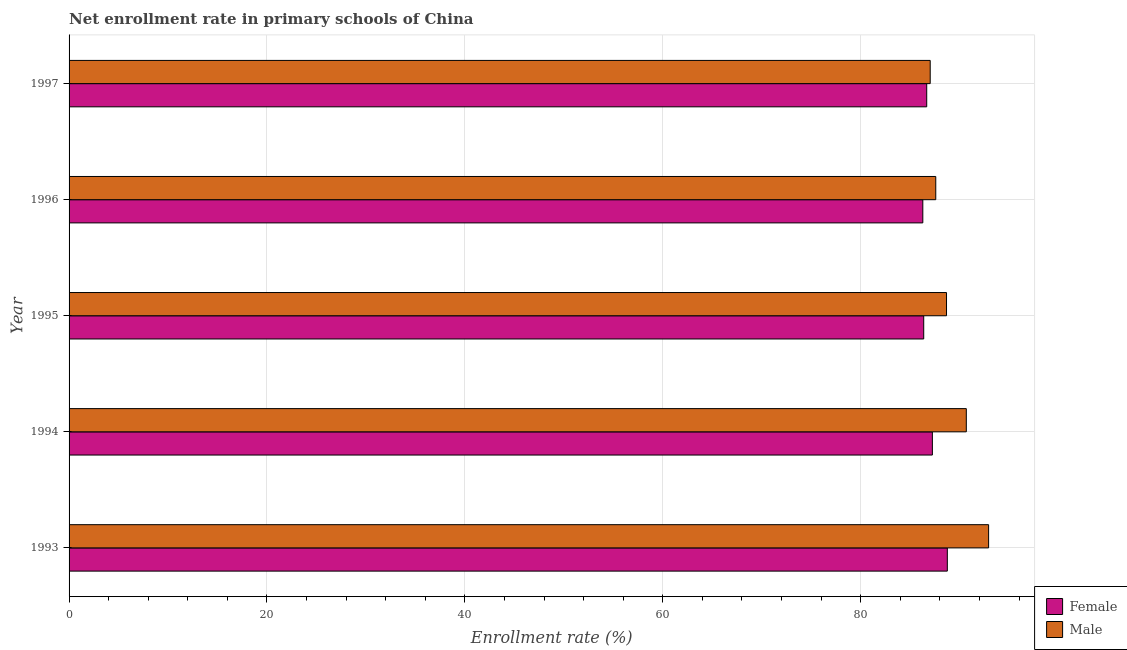How many groups of bars are there?
Give a very brief answer. 5. Are the number of bars per tick equal to the number of legend labels?
Provide a succinct answer. Yes. How many bars are there on the 5th tick from the top?
Offer a very short reply. 2. How many bars are there on the 1st tick from the bottom?
Provide a short and direct response. 2. What is the enrollment rate of male students in 1996?
Offer a terse response. 87.58. Across all years, what is the maximum enrollment rate of male students?
Provide a succinct answer. 92.93. Across all years, what is the minimum enrollment rate of male students?
Provide a succinct answer. 87.02. In which year was the enrollment rate of female students maximum?
Offer a very short reply. 1993. In which year was the enrollment rate of male students minimum?
Provide a short and direct response. 1997. What is the total enrollment rate of male students in the graph?
Keep it short and to the point. 446.88. What is the difference between the enrollment rate of female students in 1993 and that in 1994?
Give a very brief answer. 1.51. What is the difference between the enrollment rate of female students in 1996 and the enrollment rate of male students in 1993?
Your answer should be very brief. -6.65. What is the average enrollment rate of female students per year?
Provide a succinct answer. 87.06. In the year 1993, what is the difference between the enrollment rate of male students and enrollment rate of female students?
Your answer should be compact. 4.17. What is the ratio of the enrollment rate of male students in 1993 to that in 1997?
Make the answer very short. 1.07. Is the difference between the enrollment rate of male students in 1994 and 1996 greater than the difference between the enrollment rate of female students in 1994 and 1996?
Your response must be concise. Yes. What is the difference between the highest and the second highest enrollment rate of female students?
Ensure brevity in your answer.  1.51. What is the difference between the highest and the lowest enrollment rate of female students?
Keep it short and to the point. 2.48. Is the sum of the enrollment rate of male students in 1993 and 1997 greater than the maximum enrollment rate of female students across all years?
Your response must be concise. Yes. What does the 2nd bar from the top in 1997 represents?
Your answer should be compact. Female. Are all the bars in the graph horizontal?
Your response must be concise. Yes. How many years are there in the graph?
Keep it short and to the point. 5. Does the graph contain any zero values?
Give a very brief answer. No. Where does the legend appear in the graph?
Offer a terse response. Bottom right. How many legend labels are there?
Your answer should be compact. 2. What is the title of the graph?
Keep it short and to the point. Net enrollment rate in primary schools of China. Does "Highest 20% of population" appear as one of the legend labels in the graph?
Your answer should be very brief. No. What is the label or title of the X-axis?
Your response must be concise. Enrollment rate (%). What is the label or title of the Y-axis?
Make the answer very short. Year. What is the Enrollment rate (%) of Female in 1993?
Offer a terse response. 88.75. What is the Enrollment rate (%) in Male in 1993?
Offer a terse response. 92.93. What is the Enrollment rate (%) of Female in 1994?
Your answer should be very brief. 87.24. What is the Enrollment rate (%) of Male in 1994?
Provide a short and direct response. 90.67. What is the Enrollment rate (%) of Female in 1995?
Your answer should be compact. 86.37. What is the Enrollment rate (%) of Male in 1995?
Your answer should be very brief. 88.67. What is the Enrollment rate (%) of Female in 1996?
Provide a succinct answer. 86.28. What is the Enrollment rate (%) in Male in 1996?
Offer a very short reply. 87.58. What is the Enrollment rate (%) of Female in 1997?
Your answer should be compact. 86.67. What is the Enrollment rate (%) of Male in 1997?
Give a very brief answer. 87.02. Across all years, what is the maximum Enrollment rate (%) of Female?
Keep it short and to the point. 88.75. Across all years, what is the maximum Enrollment rate (%) in Male?
Offer a very short reply. 92.93. Across all years, what is the minimum Enrollment rate (%) of Female?
Offer a terse response. 86.28. Across all years, what is the minimum Enrollment rate (%) of Male?
Provide a short and direct response. 87.02. What is the total Enrollment rate (%) of Female in the graph?
Offer a terse response. 435.31. What is the total Enrollment rate (%) of Male in the graph?
Keep it short and to the point. 446.88. What is the difference between the Enrollment rate (%) in Female in 1993 and that in 1994?
Offer a very short reply. 1.51. What is the difference between the Enrollment rate (%) of Male in 1993 and that in 1994?
Offer a terse response. 2.25. What is the difference between the Enrollment rate (%) in Female in 1993 and that in 1995?
Offer a very short reply. 2.39. What is the difference between the Enrollment rate (%) of Male in 1993 and that in 1995?
Make the answer very short. 4.25. What is the difference between the Enrollment rate (%) of Female in 1993 and that in 1996?
Your answer should be very brief. 2.48. What is the difference between the Enrollment rate (%) of Male in 1993 and that in 1996?
Offer a very short reply. 5.34. What is the difference between the Enrollment rate (%) of Female in 1993 and that in 1997?
Provide a short and direct response. 2.08. What is the difference between the Enrollment rate (%) in Male in 1993 and that in 1997?
Your answer should be very brief. 5.9. What is the difference between the Enrollment rate (%) in Female in 1994 and that in 1995?
Offer a very short reply. 0.88. What is the difference between the Enrollment rate (%) in Male in 1994 and that in 1995?
Offer a very short reply. 2. What is the difference between the Enrollment rate (%) in Female in 1994 and that in 1996?
Your response must be concise. 0.97. What is the difference between the Enrollment rate (%) in Male in 1994 and that in 1996?
Provide a succinct answer. 3.09. What is the difference between the Enrollment rate (%) of Female in 1994 and that in 1997?
Offer a terse response. 0.57. What is the difference between the Enrollment rate (%) of Male in 1994 and that in 1997?
Ensure brevity in your answer.  3.65. What is the difference between the Enrollment rate (%) of Female in 1995 and that in 1996?
Your answer should be very brief. 0.09. What is the difference between the Enrollment rate (%) in Male in 1995 and that in 1996?
Your response must be concise. 1.09. What is the difference between the Enrollment rate (%) of Female in 1995 and that in 1997?
Offer a very short reply. -0.3. What is the difference between the Enrollment rate (%) in Male in 1995 and that in 1997?
Your answer should be very brief. 1.65. What is the difference between the Enrollment rate (%) of Female in 1996 and that in 1997?
Offer a very short reply. -0.39. What is the difference between the Enrollment rate (%) of Male in 1996 and that in 1997?
Keep it short and to the point. 0.56. What is the difference between the Enrollment rate (%) of Female in 1993 and the Enrollment rate (%) of Male in 1994?
Give a very brief answer. -1.92. What is the difference between the Enrollment rate (%) of Female in 1993 and the Enrollment rate (%) of Male in 1995?
Your answer should be very brief. 0.08. What is the difference between the Enrollment rate (%) of Female in 1993 and the Enrollment rate (%) of Male in 1996?
Your answer should be compact. 1.17. What is the difference between the Enrollment rate (%) of Female in 1993 and the Enrollment rate (%) of Male in 1997?
Give a very brief answer. 1.73. What is the difference between the Enrollment rate (%) in Female in 1994 and the Enrollment rate (%) in Male in 1995?
Provide a succinct answer. -1.43. What is the difference between the Enrollment rate (%) in Female in 1994 and the Enrollment rate (%) in Male in 1996?
Provide a succinct answer. -0.34. What is the difference between the Enrollment rate (%) in Female in 1994 and the Enrollment rate (%) in Male in 1997?
Keep it short and to the point. 0.22. What is the difference between the Enrollment rate (%) of Female in 1995 and the Enrollment rate (%) of Male in 1996?
Offer a very short reply. -1.22. What is the difference between the Enrollment rate (%) of Female in 1995 and the Enrollment rate (%) of Male in 1997?
Your answer should be compact. -0.66. What is the difference between the Enrollment rate (%) of Female in 1996 and the Enrollment rate (%) of Male in 1997?
Offer a very short reply. -0.75. What is the average Enrollment rate (%) in Female per year?
Give a very brief answer. 87.06. What is the average Enrollment rate (%) in Male per year?
Offer a terse response. 89.38. In the year 1993, what is the difference between the Enrollment rate (%) of Female and Enrollment rate (%) of Male?
Make the answer very short. -4.17. In the year 1994, what is the difference between the Enrollment rate (%) in Female and Enrollment rate (%) in Male?
Make the answer very short. -3.43. In the year 1995, what is the difference between the Enrollment rate (%) of Female and Enrollment rate (%) of Male?
Provide a short and direct response. -2.3. In the year 1996, what is the difference between the Enrollment rate (%) in Female and Enrollment rate (%) in Male?
Offer a very short reply. -1.31. In the year 1997, what is the difference between the Enrollment rate (%) in Female and Enrollment rate (%) in Male?
Give a very brief answer. -0.35. What is the ratio of the Enrollment rate (%) in Female in 1993 to that in 1994?
Your response must be concise. 1.02. What is the ratio of the Enrollment rate (%) in Male in 1993 to that in 1994?
Your response must be concise. 1.02. What is the ratio of the Enrollment rate (%) in Female in 1993 to that in 1995?
Ensure brevity in your answer.  1.03. What is the ratio of the Enrollment rate (%) in Male in 1993 to that in 1995?
Your answer should be very brief. 1.05. What is the ratio of the Enrollment rate (%) of Female in 1993 to that in 1996?
Offer a very short reply. 1.03. What is the ratio of the Enrollment rate (%) in Male in 1993 to that in 1996?
Make the answer very short. 1.06. What is the ratio of the Enrollment rate (%) in Male in 1993 to that in 1997?
Provide a succinct answer. 1.07. What is the ratio of the Enrollment rate (%) in Male in 1994 to that in 1995?
Offer a terse response. 1.02. What is the ratio of the Enrollment rate (%) of Female in 1994 to that in 1996?
Your answer should be compact. 1.01. What is the ratio of the Enrollment rate (%) in Male in 1994 to that in 1996?
Your response must be concise. 1.04. What is the ratio of the Enrollment rate (%) in Female in 1994 to that in 1997?
Provide a short and direct response. 1.01. What is the ratio of the Enrollment rate (%) in Male in 1994 to that in 1997?
Ensure brevity in your answer.  1.04. What is the ratio of the Enrollment rate (%) of Male in 1995 to that in 1996?
Your answer should be compact. 1.01. What is the ratio of the Enrollment rate (%) of Female in 1995 to that in 1997?
Ensure brevity in your answer.  1. What is the ratio of the Enrollment rate (%) of Male in 1995 to that in 1997?
Your answer should be very brief. 1.02. What is the ratio of the Enrollment rate (%) of Male in 1996 to that in 1997?
Keep it short and to the point. 1.01. What is the difference between the highest and the second highest Enrollment rate (%) in Female?
Your answer should be compact. 1.51. What is the difference between the highest and the second highest Enrollment rate (%) of Male?
Offer a very short reply. 2.25. What is the difference between the highest and the lowest Enrollment rate (%) in Female?
Keep it short and to the point. 2.48. What is the difference between the highest and the lowest Enrollment rate (%) in Male?
Your answer should be compact. 5.9. 